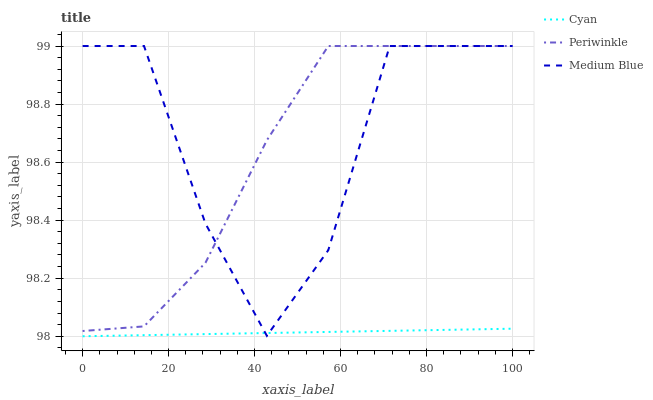Does Cyan have the minimum area under the curve?
Answer yes or no. Yes. Does Medium Blue have the maximum area under the curve?
Answer yes or no. Yes. Does Periwinkle have the minimum area under the curve?
Answer yes or no. No. Does Periwinkle have the maximum area under the curve?
Answer yes or no. No. Is Cyan the smoothest?
Answer yes or no. Yes. Is Medium Blue the roughest?
Answer yes or no. Yes. Is Periwinkle the smoothest?
Answer yes or no. No. Is Periwinkle the roughest?
Answer yes or no. No. Does Medium Blue have the lowest value?
Answer yes or no. No. Does Medium Blue have the highest value?
Answer yes or no. Yes. Is Cyan less than Periwinkle?
Answer yes or no. Yes. Is Periwinkle greater than Cyan?
Answer yes or no. Yes. Does Cyan intersect Medium Blue?
Answer yes or no. Yes. Is Cyan less than Medium Blue?
Answer yes or no. No. Is Cyan greater than Medium Blue?
Answer yes or no. No. Does Cyan intersect Periwinkle?
Answer yes or no. No. 